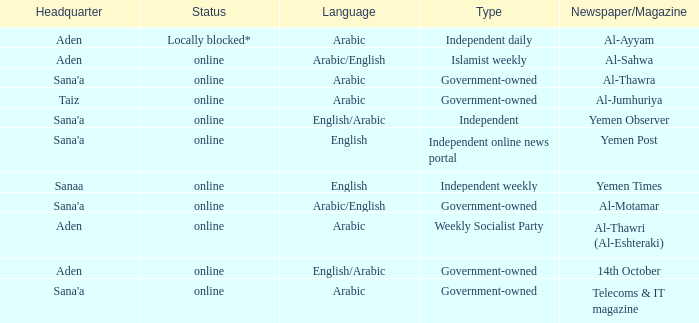In the context of newspapers and magazines, what does "type" represent when discussing telecoms & it magazine? Government-owned. 